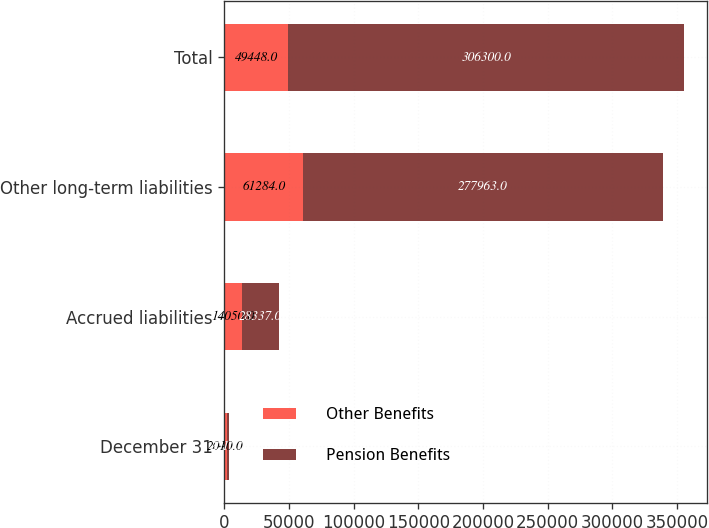<chart> <loc_0><loc_0><loc_500><loc_500><stacked_bar_chart><ecel><fcel>December 31<fcel>Accrued liabilities<fcel>Other long-term liabilities<fcel>Total<nl><fcel>Other Benefits<fcel>2010<fcel>14050<fcel>61284<fcel>49448<nl><fcel>Pension Benefits<fcel>2010<fcel>28337<fcel>277963<fcel>306300<nl></chart> 